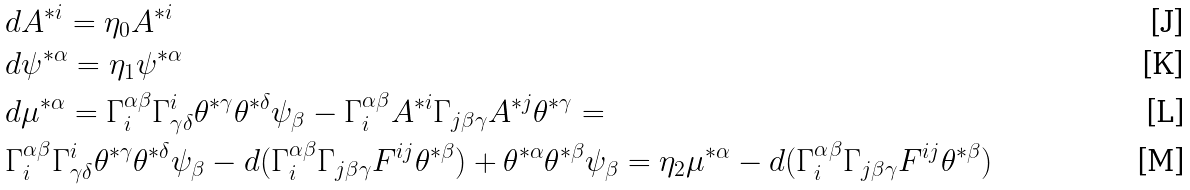<formula> <loc_0><loc_0><loc_500><loc_500>& d A ^ { * i } = \eta _ { 0 } A ^ { * i } \\ & d \psi ^ { * \alpha } = \eta _ { 1 } \psi ^ { * \alpha } \\ & d \mu ^ { * \alpha } = \Gamma _ { i } ^ { \alpha \beta } \Gamma ^ { i } _ { \gamma \delta } \theta ^ { * \gamma } \theta ^ { * \delta } \psi _ { \beta } - \Gamma _ { i } ^ { \alpha \beta } A ^ { * i } \Gamma _ { j \beta \gamma } A ^ { * j } \theta ^ { * \gamma } = \\ & \Gamma _ { i } ^ { \alpha \beta } \Gamma ^ { i } _ { \gamma \delta } \theta ^ { * \gamma } \theta ^ { * \delta } \psi _ { \beta } - d ( \Gamma _ { i } ^ { \alpha \beta } \Gamma _ { j \beta \gamma } F ^ { i j } \theta ^ { * \beta } ) + \theta ^ { * \alpha } \theta ^ { * \beta } \psi _ { \beta } = \eta _ { 2 } \mu ^ { * \alpha } - d ( \Gamma _ { i } ^ { \alpha \beta } \Gamma _ { j \beta \gamma } F ^ { i j } \theta ^ { * \beta } )</formula> 